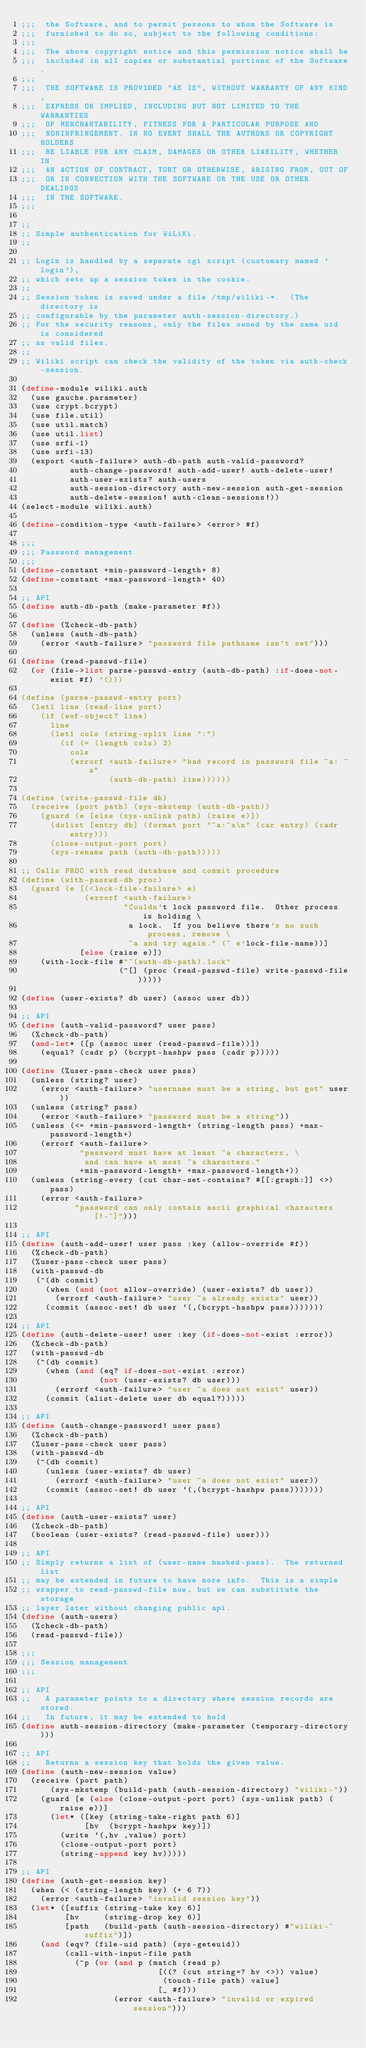Convert code to text. <code><loc_0><loc_0><loc_500><loc_500><_Scheme_>;;;  the Software, and to permit persons to whom the Software is
;;;  furnished to do so, subject to the following conditions:
;;;
;;;  The above copyright notice and this permission notice shall be
;;;  included in all copies or substantial portions of the Software.
;;;
;;;  THE SOFTWARE IS PROVIDED "AS IS", WITHOUT WARRANTY OF ANY KIND,
;;;  EXPRESS OR IMPLIED, INCLUDING BUT NOT LIMITED TO THE WARRANTIES
;;;  OF MERCHANTABILITY, FITNESS FOR A PARTICULAR PURPOSE AND
;;;  NONINFRINGEMENT. IN NO EVENT SHALL THE AUTHORS OR COPYRIGHT HOLDERS
;;;  BE LIABLE FOR ANY CLAIM, DAMAGES OR OTHER LIABILITY, WHETHER IN
;;;  AN ACTION OF CONTRACT, TORT OR OTHERWISE, ARISING FROM, OUT OF
;;;  OR IN CONNECTION WITH THE SOFTWARE OR THE USE OR OTHER DEALINGS
;;;  IN THE SOFTWARE.
;;;

;;
;; Simple authentication for WiLiKi.
;;

;; Login is handled by a separate cgi script (customary named 'login'),
;; which sets up a session token in the cookie.
;;
;; Session token is saved under a file /tmp/wiliki-*.  (The directory is
;; configurable by the parameter auth-session-directory.)
;; For the security reasons, only the files owned by the same uid is considered
;; as valid files.
;;
;; Wiliki script can check the validity of the token via auth-check-session.

(define-module wiliki.auth
  (use gauche.parameter)
  (use crypt.bcrypt)
  (use file.util)
  (use util.match)
  (use util.list)
  (use srfi-1)
  (use srfi-13)
  (export <auth-failure> auth-db-path auth-valid-password?
          auth-change-password! auth-add-user! auth-delete-user!
          auth-user-exists? auth-users
          auth-session-directory auth-new-session auth-get-session
          auth-delete-session! auth-clean-sessions!))
(select-module wiliki.auth)

(define-condition-type <auth-failure> <error> #f)

;;;
;;; Password management
;;;
(define-constant +min-password-length+ 8)
(define-constant +max-password-length+ 40)

;; API
(define auth-db-path (make-parameter #f))

(define (%check-db-path)
  (unless (auth-db-path)
    (error <auth-failure> "password file pathname isn't set")))

(define (read-passwd-file)
  (or (file->list parse-passwd-entry (auth-db-path) :if-does-not-exist #f) '()))

(define (parse-passwd-entry port)
  (let1 line (read-line port)
    (if (eof-object? line)
      line
      (let1 cols (string-split line ":")
        (if (= (length cols) 2)
          cols
          (errorf <auth-failure> "bad record in password file ~a: ~a"
                  (auth-db-path) line))))))

(define (write-passwd-file db)
  (receive (port path) (sys-mkstemp (auth-db-path))
    (guard (e [else (sys-unlink path) (raise e)])
      (dolist [entry db] (format port "~a:~a\n" (car entry) (cadr entry)))
      (close-output-port port)
      (sys-rename path (auth-db-path)))))

;; Calls PROC with read database and commit procedure
(define (with-passwd-db proc)
  (guard (e [(<lock-file-failure> e)
             (errorf <auth-failure>
                     "Couldn't lock password file.  Other process is holding \
                      a lock.  If you believe there's no such process, remove \
                      ~a and try again." (~ e'lock-file-name))]
            [else (raise e)])
    (with-lock-file #"~(auth-db-path).lock"
                    (^[] (proc (read-passwd-file) write-passwd-file)))))

(define (user-exists? db user) (assoc user db))

;; API
(define (auth-valid-password? user pass)
  (%check-db-path)
  (and-let* ([p (assoc user (read-passwd-file))])
    (equal? (cadr p) (bcrypt-hashpw pass (cadr p)))))

(define (%user-pass-check user pass)
  (unless (string? user)
    (error <auth-failure> "username must be a string, but got" user))
  (unless (string? pass)
    (error <auth-failure> "password must be a string"))
  (unless (<= +min-password-length+ (string-length pass) +max-password-length+)
    (errorf <auth-failure>
            "password must have at least ~a characters, \
             and can have at most ~a characters."
            +min-password-length+ +max-password-length+))
  (unless (string-every (cut char-set-contains? #[[:graph:]] <>) pass)
    (error <auth-failure>
           "password can only contain ascii graphical characters [!-~]")))

;; API
(define (auth-add-user! user pass :key (allow-override #f))
  (%check-db-path)
  (%user-pass-check user pass)
  (with-passwd-db
   (^(db commit)
     (when (and (not allow-override) (user-exists? db user))
       (errorf <auth-failure> "user ~a already exists" user))
     (commit (assoc-set! db user `(,(bcrypt-hashpw pass)))))))

;; API
(define (auth-delete-user! user :key (if-does-not-exist :error))
  (%check-db-path)
  (with-passwd-db
   (^(db commit)
     (when (and (eq? if-does-not-exist :error)
                (not (user-exists? db user)))
       (errorf <auth-failure> "user ~a does not exist" user))
     (commit (alist-delete user db equal?)))))

;; API
(define (auth-change-password! user pass)
  (%check-db-path)
  (%user-pass-check user pass)
  (with-passwd-db
   (^(db commit)
     (unless (user-exists? db user)
       (errorf <auth-failure> "user ~a does not exist" user))
     (commit (assoc-set! db user `(,(bcrypt-hashpw pass)))))))

;; API
(define (auth-user-exists? user)
  (%check-db-path)
  (boolean (user-exists? (read-passwd-file) user)))

;; API
;; Simply returns a list of (user-name hashed-pass).  The returned list
;; may be extended in future to have more info.  This is a simple
;; wrapper to read-passwd-file now, but we can substitute the storage
;; layer later without changing public api.
(define (auth-users)
  (%check-db-path)
  (read-passwd-file))

;;;
;;; Session management
;;;

;; API
;;   A parameter points to a directory where session records are stored.
;;   In future, it may be extended to hold
(define auth-session-directory (make-parameter (temporary-directory)))

;; API
;;   Returns a session key that holds the given value.
(define (auth-new-session value)
  (receive (port path)
      (sys-mkstemp (build-path (auth-session-directory) "wiliki-"))
    (guard [e (else (close-output-port port) (sys-unlink path) (raise e))]
      (let* ([key (string-take-right path 6)]
             [hv  (bcrypt-hashpw key)])
        (write `(,hv ,value) port)
        (close-output-port port)
        (string-append key hv)))))

;; API
(define (auth-get-session key)
  (when (< (string-length key) (+ 6 7))
    (error <auth-failure> "invalid session key"))
  (let* ([suffix (string-take key 6)]
         [hv     (string-drop key 6)]
         [path   (build-path (auth-session-directory) #"wiliki-~suffix")])
    (and (eqv? (file-uid path) (sys-geteuid))
         (call-with-input-file path
           (^p (or (and p (match (read p)
                            [((? (cut string=? hv <>)) value)
                             (touch-file path) value]
                            [_ #f]))
                   (error <auth-failure> "invalid or expired session")))</code> 